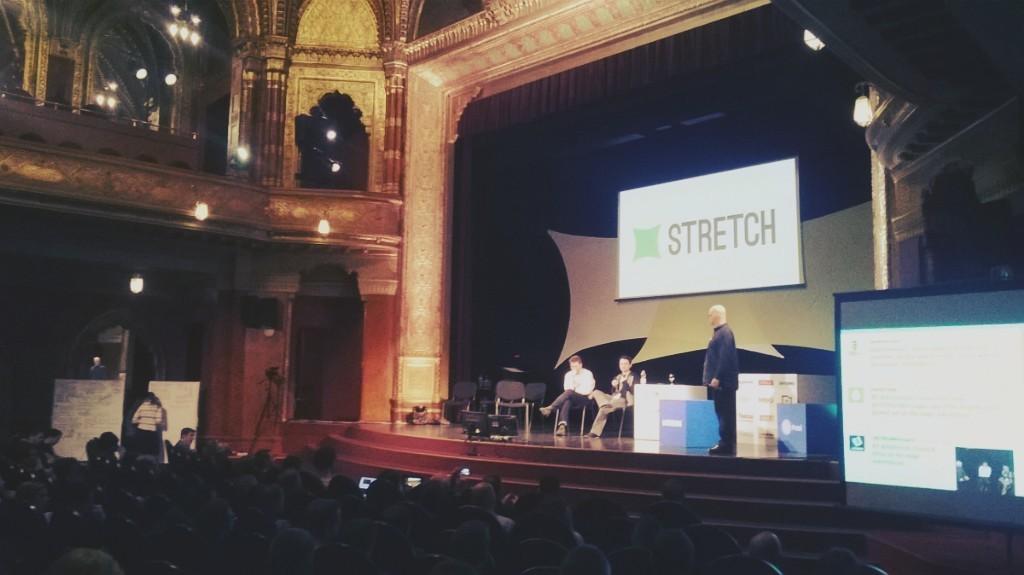What is the word on the screen?
Offer a very short reply. Stretch. 